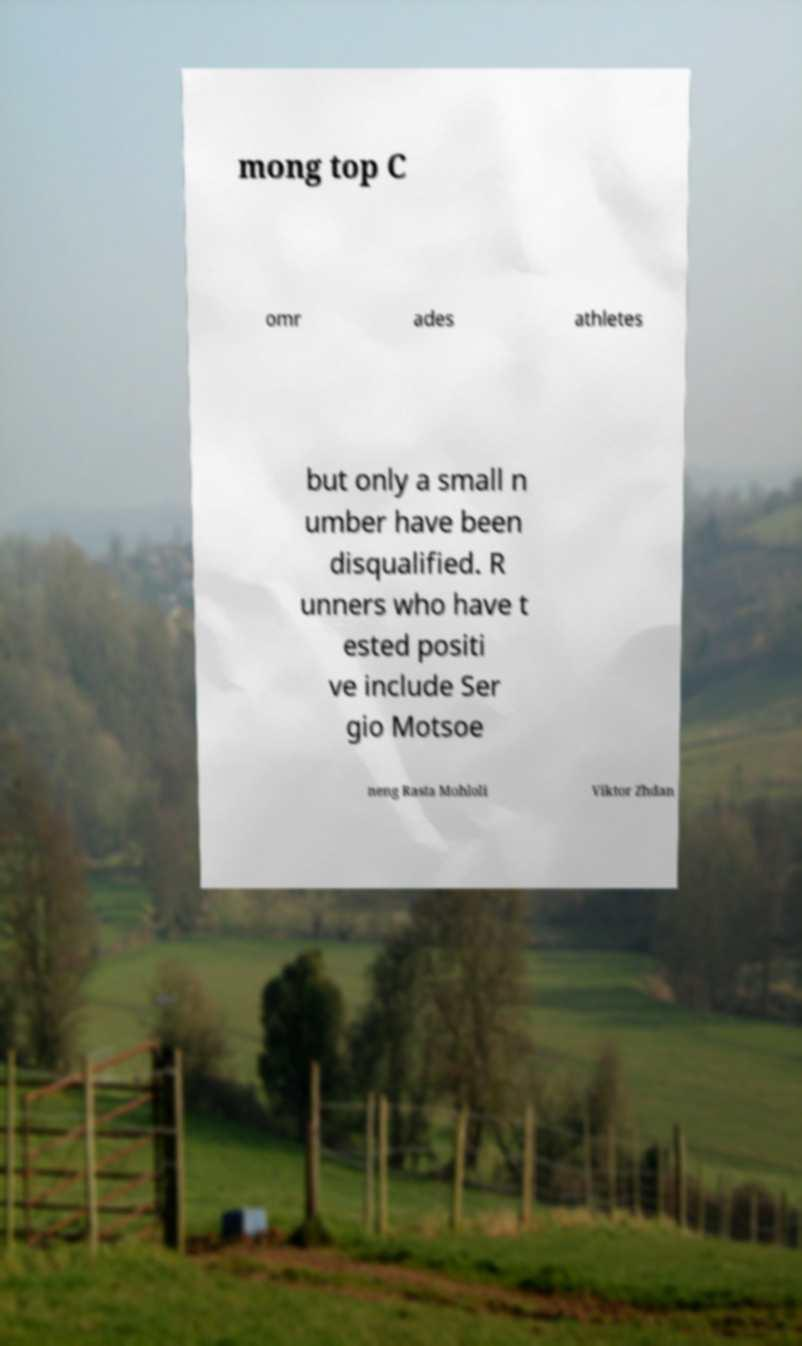There's text embedded in this image that I need extracted. Can you transcribe it verbatim? mong top C omr ades athletes but only a small n umber have been disqualified. R unners who have t ested positi ve include Ser gio Motsoe neng Rasta Mohloli Viktor Zhdan 